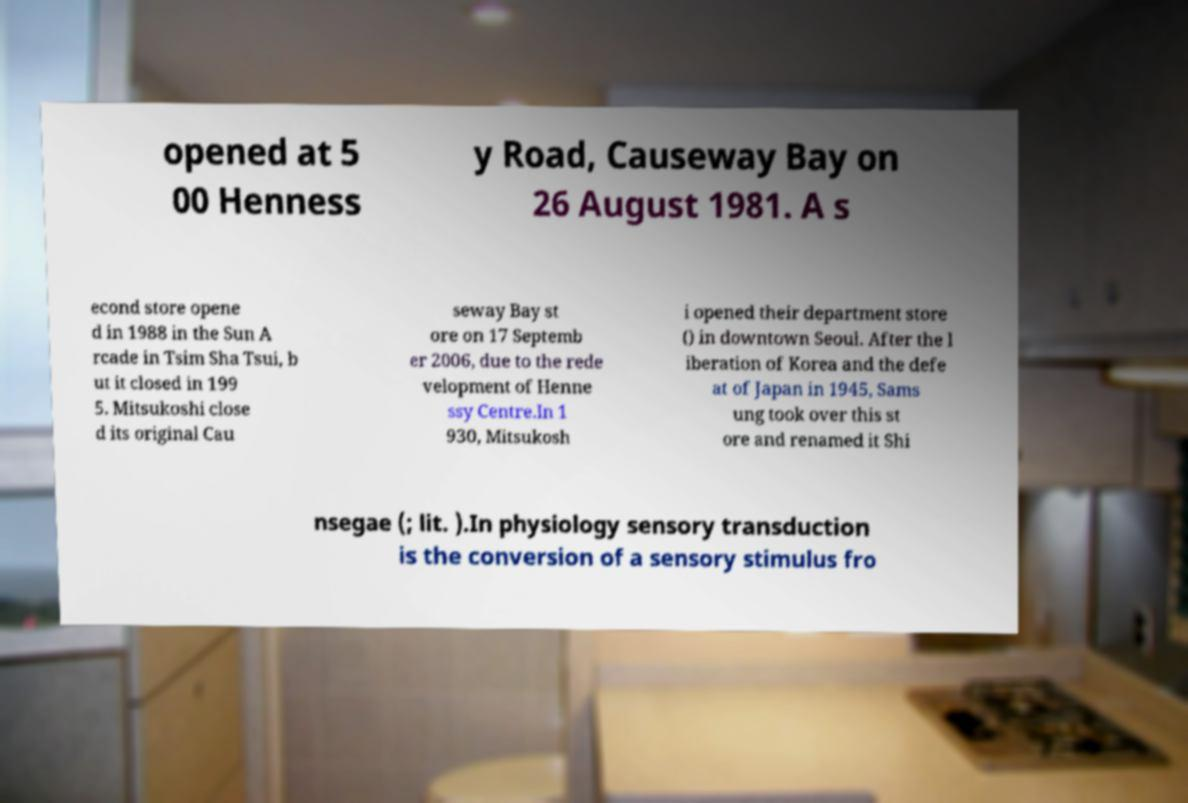Could you assist in decoding the text presented in this image and type it out clearly? opened at 5 00 Henness y Road, Causeway Bay on 26 August 1981. A s econd store opene d in 1988 in the Sun A rcade in Tsim Sha Tsui, b ut it closed in 199 5. Mitsukoshi close d its original Cau seway Bay st ore on 17 Septemb er 2006, due to the rede velopment of Henne ssy Centre.In 1 930, Mitsukosh i opened their department store () in downtown Seoul. After the l iberation of Korea and the defe at of Japan in 1945, Sams ung took over this st ore and renamed it Shi nsegae (; lit. ).In physiology sensory transduction is the conversion of a sensory stimulus fro 